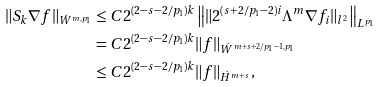<formula> <loc_0><loc_0><loc_500><loc_500>\| S _ { k } \nabla f \| _ { \dot { W } ^ { m , p _ { 1 } } } & \leq C 2 ^ { ( 2 - s - 2 / p _ { 1 } ) k } \left \| \| 2 ^ { ( s + 2 / p _ { 1 } - 2 ) i } \Lambda ^ { m } \nabla f _ { i } \| _ { l ^ { 2 } } \right \| _ { L ^ { p _ { 1 } } } \\ & = C 2 ^ { ( 2 - s - 2 / p _ { 1 } ) k } \| f \| _ { \dot { W } ^ { m + s + 2 / p _ { 1 } - 1 , p _ { 1 } } } \\ & \leq C 2 ^ { ( 2 - s - 2 / p _ { 1 } ) k } \| f \| _ { \dot { H } ^ { m + s } } ,</formula> 